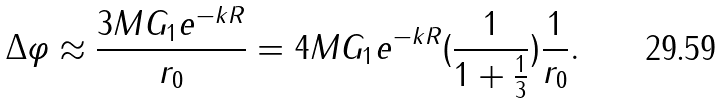<formula> <loc_0><loc_0><loc_500><loc_500>\Delta \varphi \approx \frac { 3 M G _ { 1 } e ^ { - k R } } { r _ { 0 } } = 4 M G _ { 1 } e ^ { - k R } ( \frac { 1 } { 1 + \frac { 1 } { 3 } } ) \frac { 1 } { r _ { 0 } } .</formula> 